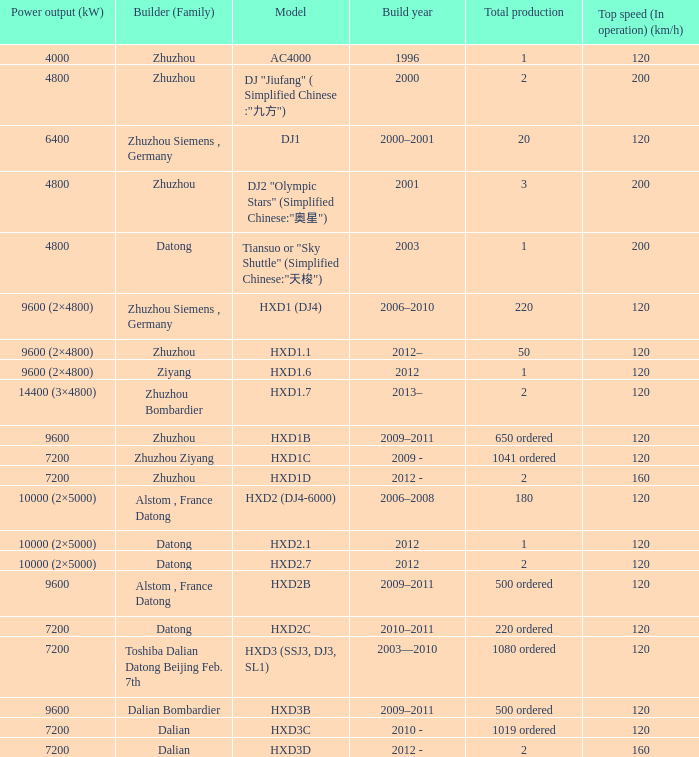What is the power output (kw) of model hxd2b? 9600.0. 